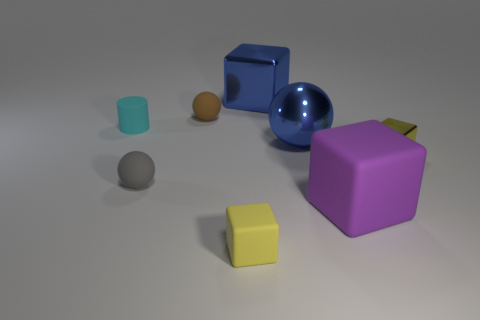There is a metal thing that is behind the brown rubber thing; does it have the same color as the large metallic object that is in front of the small matte cylinder?
Give a very brief answer. Yes. What is the color of the other matte object that is the same shape as the big purple rubber thing?
Your answer should be very brief. Yellow. Is there any other thing that is the same shape as the tiny cyan matte object?
Ensure brevity in your answer.  No. There is a large thing that is in front of the small yellow metallic thing; is it the same shape as the object left of the gray matte sphere?
Give a very brief answer. No. There is a brown matte ball; is its size the same as the rubber cube on the left side of the purple object?
Your answer should be very brief. Yes. Are there more tiny brown things than big blue shiny things?
Your answer should be compact. No. Do the tiny cube that is to the left of the yellow shiny object and the ball to the right of the small rubber cube have the same material?
Your response must be concise. No. What is the material of the cylinder?
Your response must be concise. Rubber. Are there more tiny metallic things in front of the yellow metal thing than small gray objects?
Offer a very short reply. No. How many small matte balls are left of the small matte sphere behind the metal thing to the right of the big matte cube?
Keep it short and to the point. 1. 